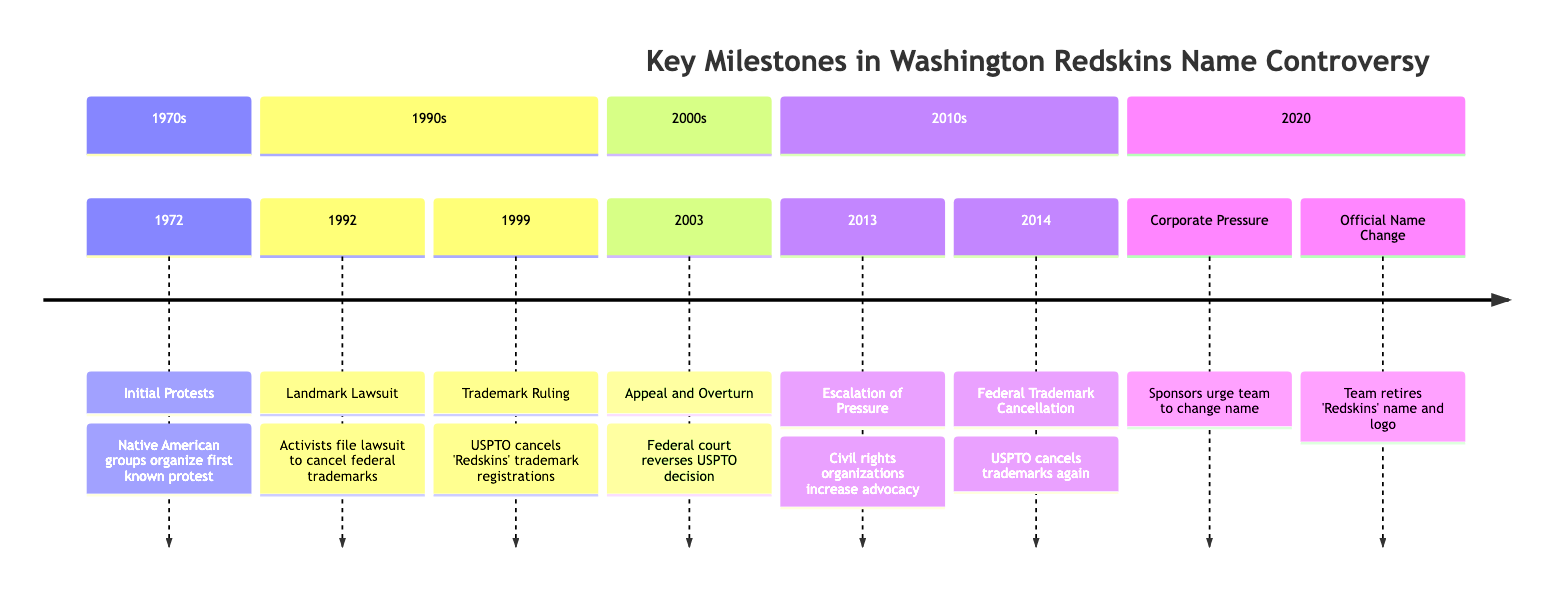What year did the initial protests against the Redskins name occur? The timeline displays that initial protests occurred in 1972. By locating the first event on the timeline, we can see that this event is labeled with the year 1972.
Answer: 1972 Who organized the initial protests? The event description for "Initial Protests" states that Native American groups, including the National Congress of American Indians (NCAI), organized the first known protest. By referring to the associated description, we can conclude that they were the organizers.
Answer: Native American groups What was the outcome of the trademark ruling in 1999? According to the timeline, the US Patent and Trademark Office (USPTO) ruled in favor of the plaintiffs by canceling the 'Redskins' trademark registrations during the event in 1999. This outcome is directly described in the event details.
Answer: Trademark registrations canceled What significant event happened in 2013 related to the team name? The section for 2013 indicates an event labeled "Escalation of Pressure," where civil rights organizations increased their advocacy against the team's name. This is noted in the event description for that year.
Answer: Escalation of Pressure What caused the official name change in 2020? The timeline mentions that significant corporate pressure from major sponsors urged the team to change its name amid nationwide racial justice protests. Looking at the corresponding event in 2020 provides the necessary context for this change.
Answer: Corporate pressure Which lawsuit sought to cancel federal trademark registrations? The event labeled "Landmark Lawsuit" in 1992 specified that a group of Native American activists filed this lawsuit seeking to cancel federal trademark registrations. This information is summarized in the event's description on the timeline.
Answer: Landmark Lawsuit How many total events are shown in the timeline? Counting the events listed in the timeline, there are a total of seven distinct milestones highlighted. Each milestone represents a key event in the controversy, and simply counting the events displayed reveals the total.
Answer: 7 What year did the USPTO cancel the trademarks again? The timeline indicates that the USPTO canceled the 'Redskins' trademarks again in 2014. This information is found in the event entry for that year, clearly noting the cancellation.
Answer: 2014 What event directly followed the year 2003? In the timeline, the event labeled "Escalation of Pressure" is shown for the year 2013, which follows the 2003 event ("Appeal and Overturn"). This requires looking at the years chronologically in the timeline to find the subsequent event.
Answer: Escalation of Pressure 